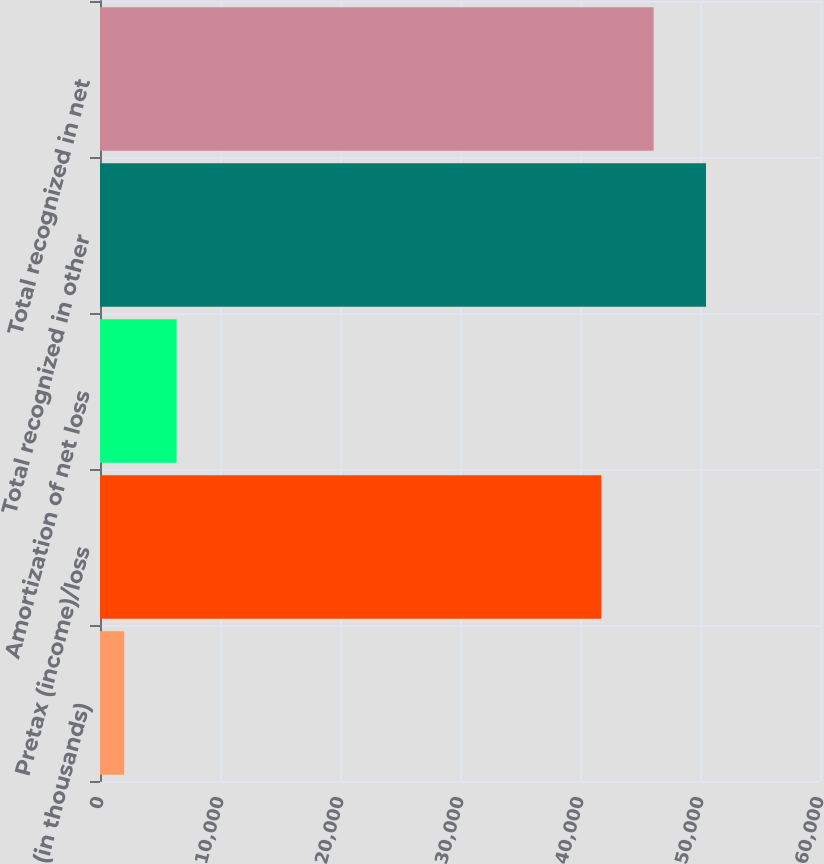Convert chart. <chart><loc_0><loc_0><loc_500><loc_500><bar_chart><fcel>(in thousands)<fcel>Pretax (income)/loss<fcel>Amortization of net loss<fcel>Total recognized in other<fcel>Total recognized in net<nl><fcel>2013<fcel>41767<fcel>6379.4<fcel>50499.8<fcel>46133.4<nl></chart> 